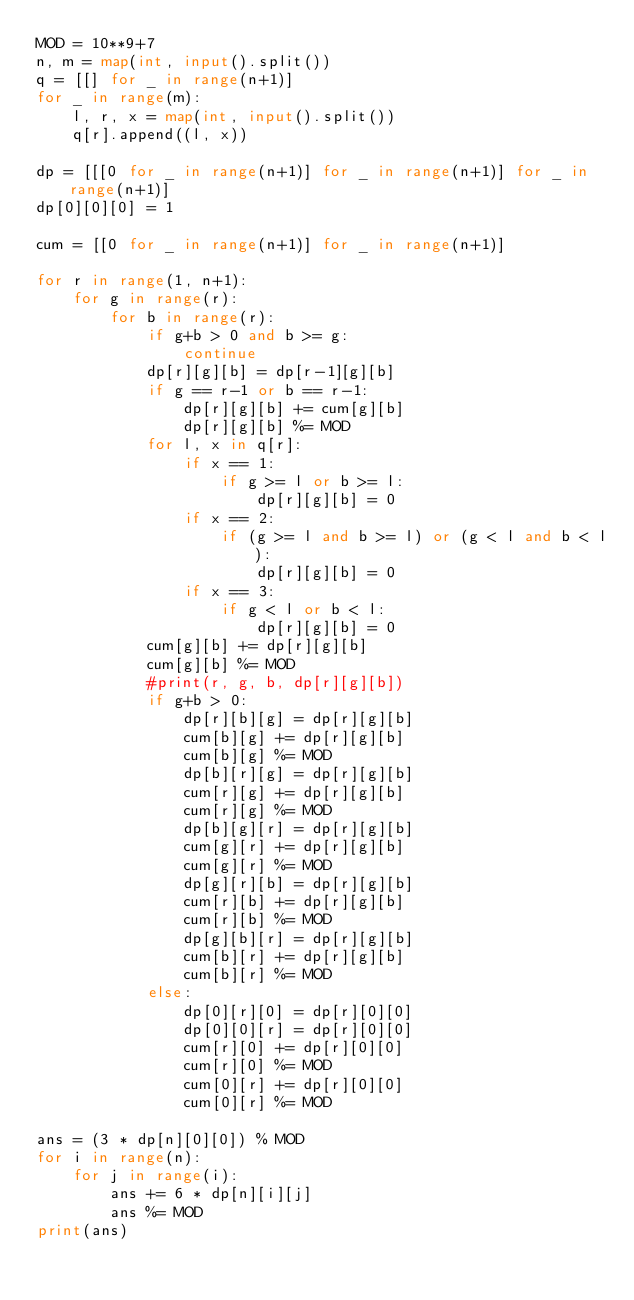<code> <loc_0><loc_0><loc_500><loc_500><_Python_>MOD = 10**9+7
n, m = map(int, input().split())
q = [[] for _ in range(n+1)]
for _ in range(m):
	l, r, x = map(int, input().split())
	q[r].append((l, x))

dp = [[[0 for _ in range(n+1)] for _ in range(n+1)] for _ in range(n+1)]
dp[0][0][0] = 1

cum = [[0 for _ in range(n+1)] for _ in range(n+1)]

for r in range(1, n+1):
	for g in range(r):
		for b in range(r):
			if g+b > 0 and b >= g:
				continue
			dp[r][g][b] = dp[r-1][g][b]
			if g == r-1 or b == r-1:
				dp[r][g][b] += cum[g][b]
				dp[r][g][b] %= MOD
			for l, x in q[r]:
				if x == 1:
					if g >= l or b >= l:
						dp[r][g][b] = 0
				if x == 2:
					if (g >= l and b >= l) or (g < l and b < l):
						dp[r][g][b] = 0
				if x == 3:
					if g < l or b < l:
						dp[r][g][b] = 0
			cum[g][b] += dp[r][g][b]
			cum[g][b] %= MOD
			#print(r, g, b, dp[r][g][b])
			if g+b > 0:
				dp[r][b][g] = dp[r][g][b]
				cum[b][g] += dp[r][g][b]
				cum[b][g] %= MOD
				dp[b][r][g] = dp[r][g][b]
				cum[r][g] += dp[r][g][b]
				cum[r][g] %= MOD
				dp[b][g][r] = dp[r][g][b]
				cum[g][r] += dp[r][g][b]
				cum[g][r] %= MOD
				dp[g][r][b] = dp[r][g][b]
				cum[r][b] += dp[r][g][b]
				cum[r][b] %= MOD
				dp[g][b][r] = dp[r][g][b]
				cum[b][r] += dp[r][g][b]
				cum[b][r] %= MOD
			else:
				dp[0][r][0] = dp[r][0][0]
				dp[0][0][r] = dp[r][0][0]
				cum[r][0] += dp[r][0][0]
				cum[r][0] %= MOD
				cum[0][r] += dp[r][0][0]
				cum[0][r] %= MOD

ans = (3 * dp[n][0][0]) % MOD
for i in range(n):
	for j in range(i):
		ans += 6 * dp[n][i][j]
		ans %= MOD
print(ans)</code> 